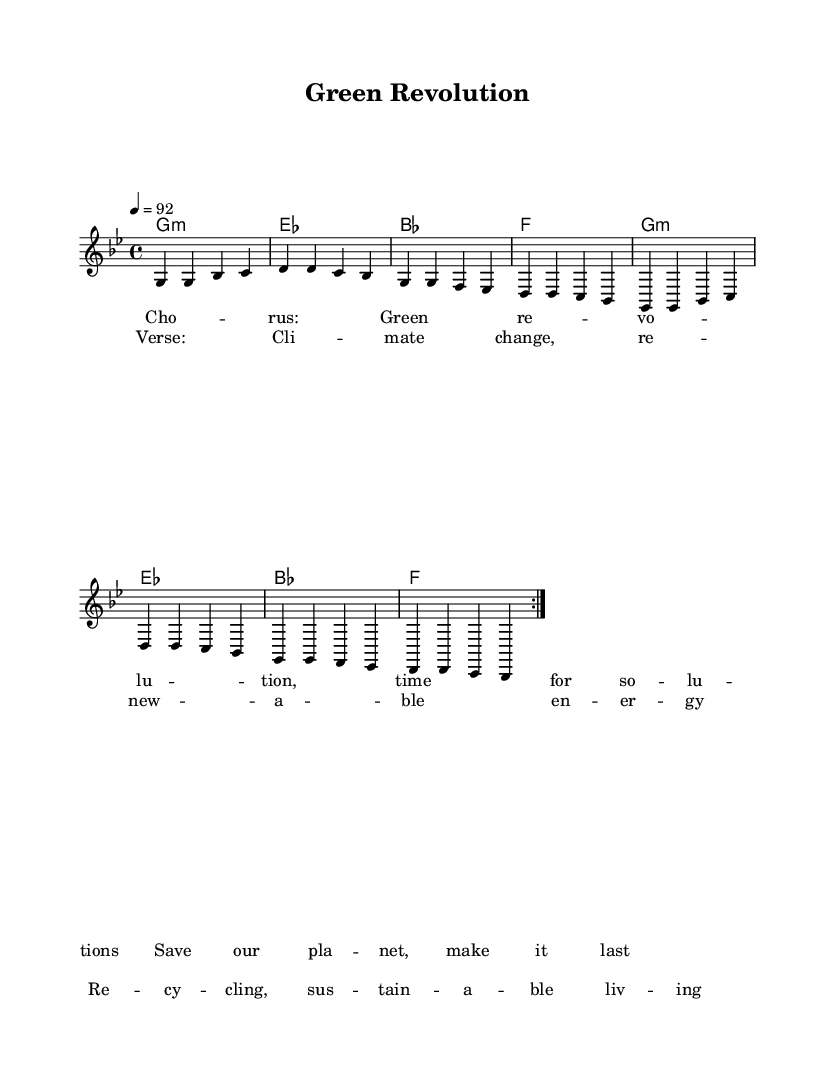What is the key signature of this music? The key signature is G minor, which has two flats (B♭ and E♭). This is determined by looking at the key signature indicated at the beginning of the score.
Answer: G minor What is the time signature of this piece? The time signature is 4/4, which is indicated at the beginning of the score, meaning there are four beats per measure.
Answer: 4/4 What is the tempo marking for this piece? The tempo is marked at 92 beats per minute, which is shown in the score. This indicates the speed at which the piece should be played.
Answer: 92 How many chords are there in the repeated section of the harmony? In each repeat of the harmony section, there are four distinct chords listed, which repeat two times for the given section in the score.
Answer: Four What is the main theme addressed in the lyrics? The lyrics focus on themes of climate change, renewable energy, recycling, and sustainable living, as indicated by the placeholder lyrics in the verse.
Answer: Sustainability How many times is the chorus repeated in the score? The chorus section is marked to be repeated twice, as indicated by the repeat signs in the score. This suggests that it is a significant part of the song, often in rap music for emphasis.
Answer: Two 